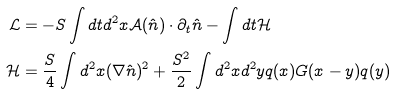Convert formula to latex. <formula><loc_0><loc_0><loc_500><loc_500>\mathcal { L } & = - S \int d t d ^ { 2 } x \mathcal { A } ( \hat { n } ) \cdot \partial _ { t } \hat { n } - \int d t \mathcal { H } \\ \mathcal { H } & = \frac { S } { 4 } \int d ^ { 2 } x ( \nabla \hat { n } ) ^ { 2 } + \frac { S ^ { 2 } } { 2 } \int d ^ { 2 } x d ^ { 2 } y q ( x ) G ( x - y ) q ( y )</formula> 